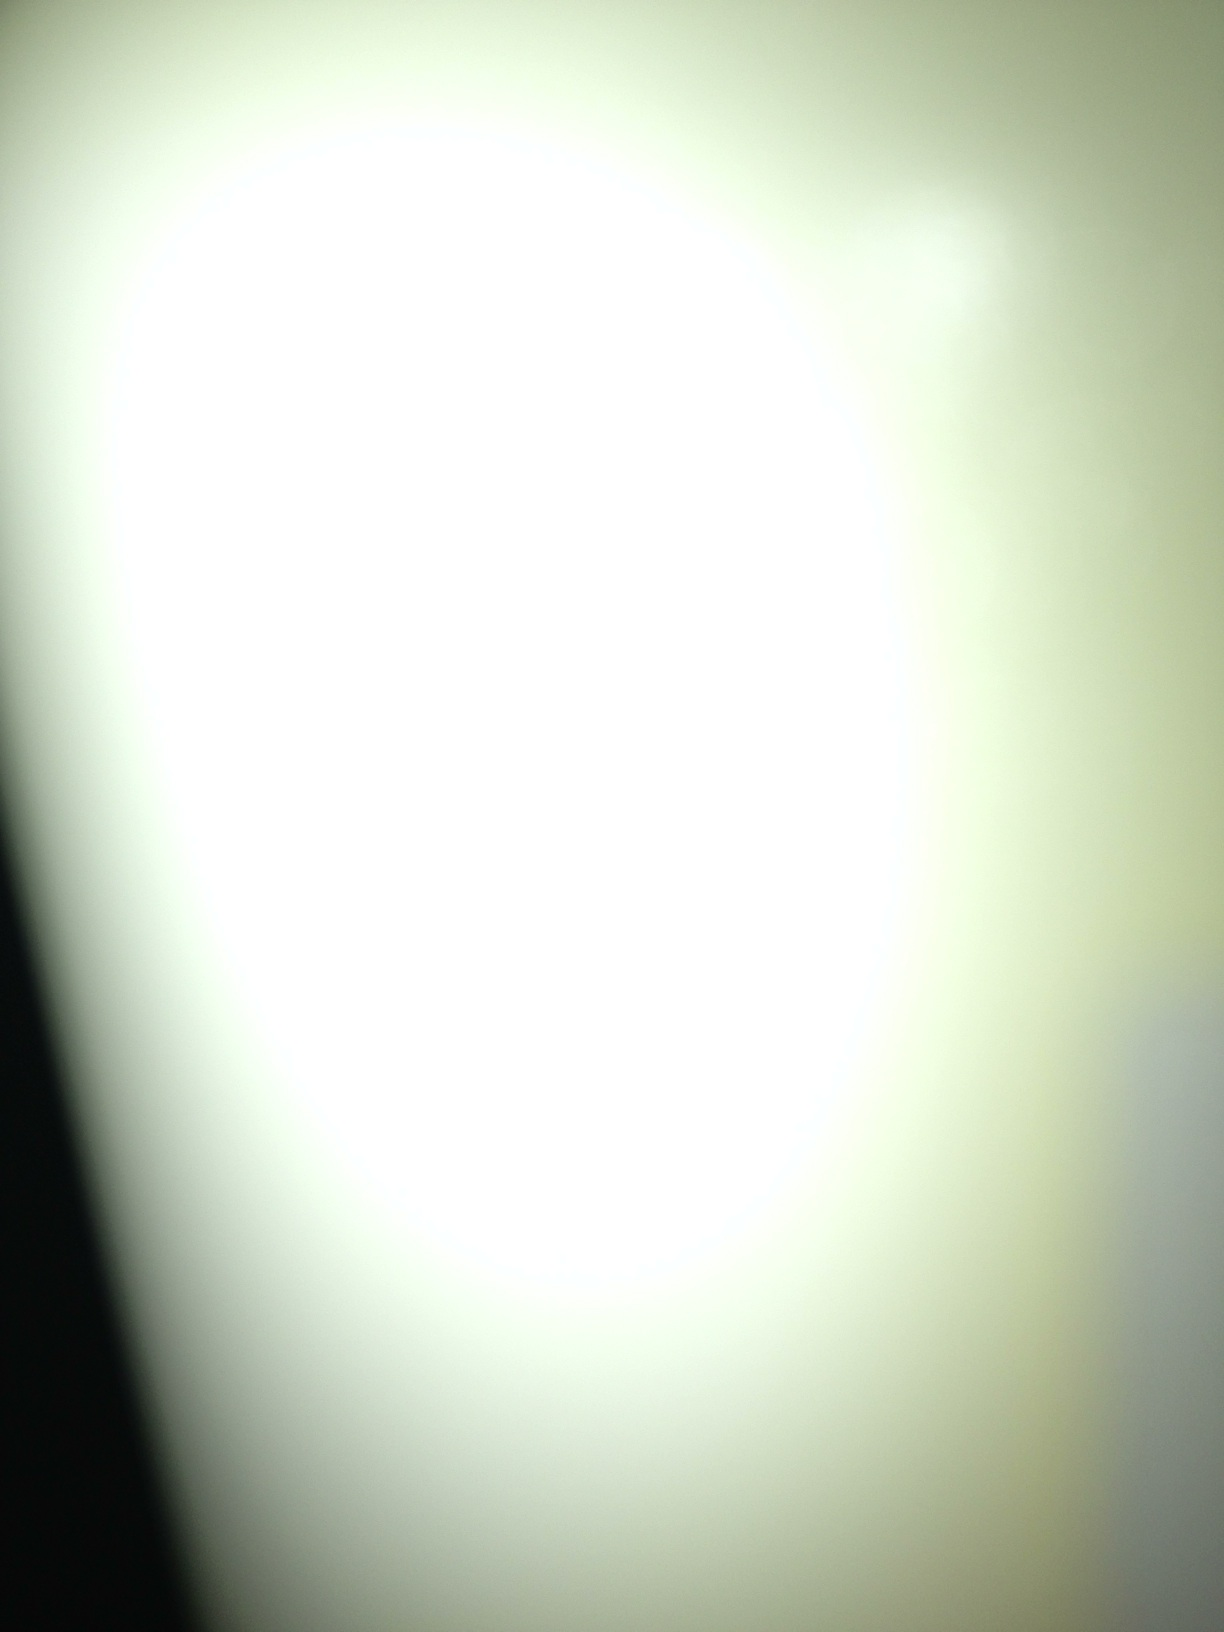Can you describe a short sci-fi scenario inspired by this image? In a futuristic world, humanity discovers a mysterious orb that emits a powerful, blinding light. Scientists believe it's a gateway to an alternate dimension. Dr. Elena Stone, a renowned physicist, volunteers to venture into the light. As she steps through, she finds herself in a realm where the laws of physics bend, and she must navigate this new, surreal landscape to discover its secrets and find a way back home. 